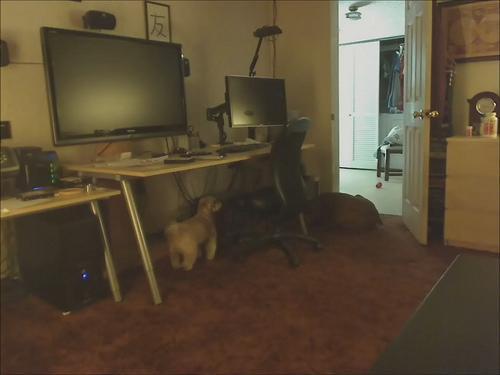How many monitors are on the table?
Give a very brief answer. 2. How many chairs are in the room?
Give a very brief answer. 1. 